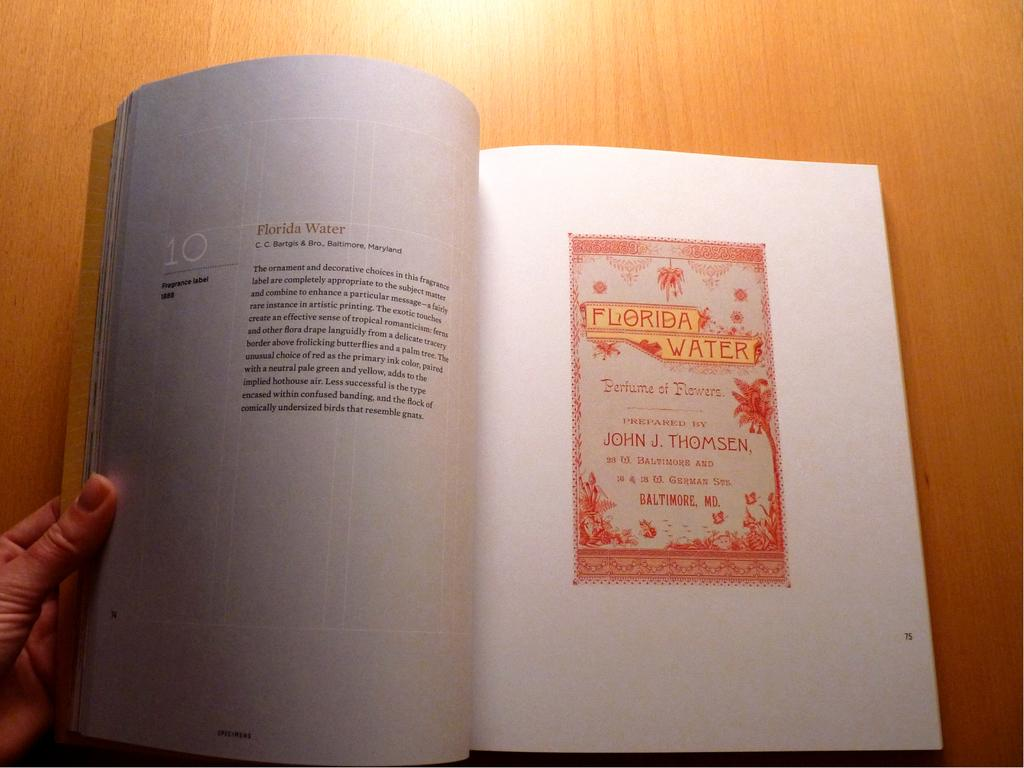<image>
Summarize the visual content of the image. A book opened to a page about Florida water. 